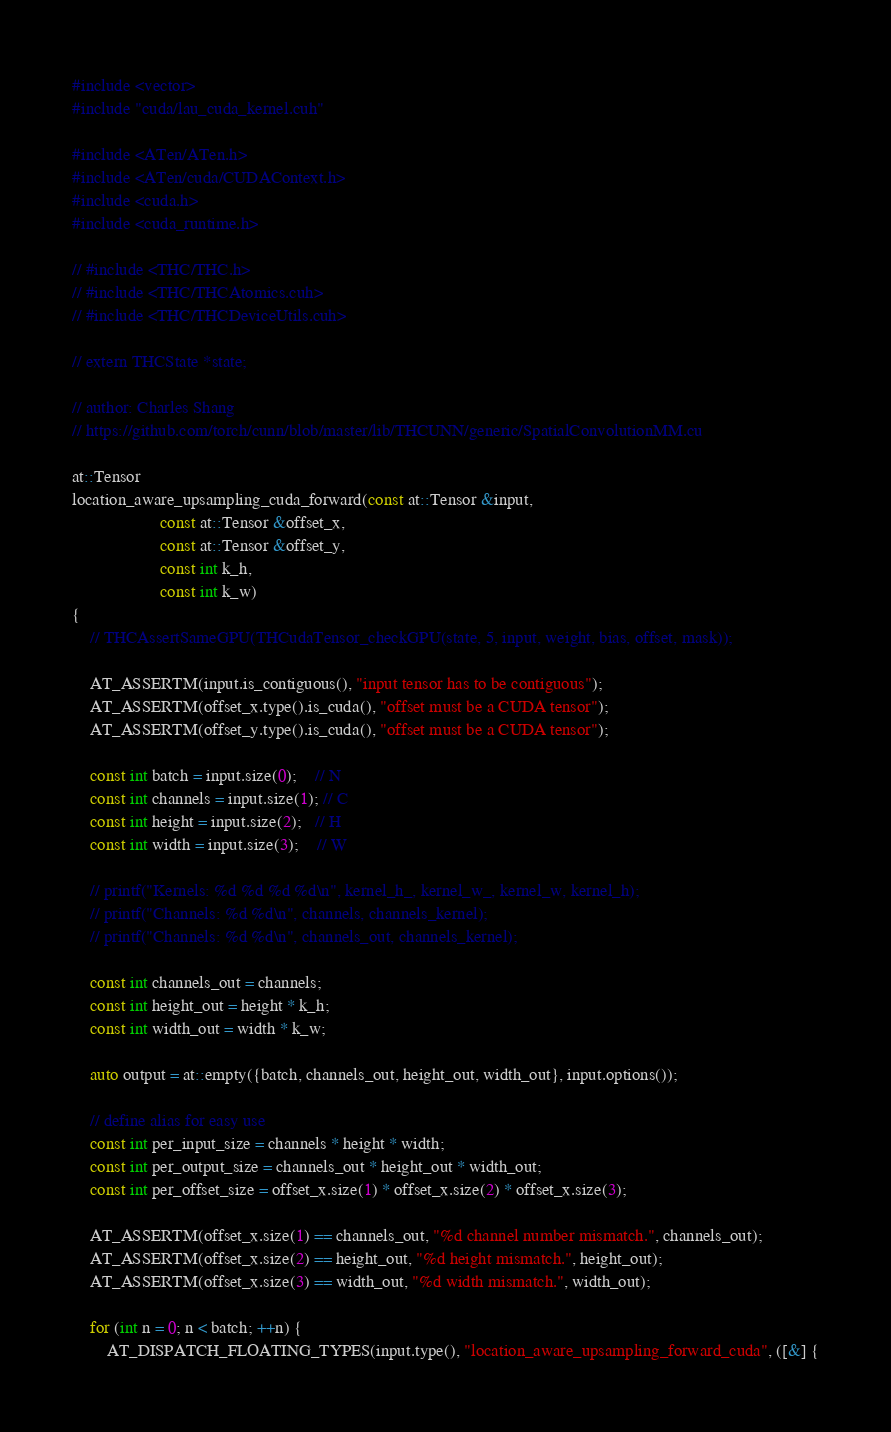<code> <loc_0><loc_0><loc_500><loc_500><_Cuda_>#include <vector>
#include "cuda/lau_cuda_kernel.cuh"

#include <ATen/ATen.h>
#include <ATen/cuda/CUDAContext.h>
#include <cuda.h>
#include <cuda_runtime.h>

// #include <THC/THC.h>
// #include <THC/THCAtomics.cuh>
// #include <THC/THCDeviceUtils.cuh>

// extern THCState *state;

// author: Charles Shang
// https://github.com/torch/cunn/blob/master/lib/THCUNN/generic/SpatialConvolutionMM.cu

at::Tensor
location_aware_upsampling_cuda_forward(const at::Tensor &input,
                    const at::Tensor &offset_x, 
                    const at::Tensor &offset_y, 
                    const int k_h,
                    const int k_w)
{
    // THCAssertSameGPU(THCudaTensor_checkGPU(state, 5, input, weight, bias, offset, mask));

    AT_ASSERTM(input.is_contiguous(), "input tensor has to be contiguous");
    AT_ASSERTM(offset_x.type().is_cuda(), "offset must be a CUDA tensor");
    AT_ASSERTM(offset_y.type().is_cuda(), "offset must be a CUDA tensor");

    const int batch = input.size(0);    // N
    const int channels = input.size(1); // C
    const int height = input.size(2);   // H
    const int width = input.size(3);    // W

    // printf("Kernels: %d %d %d %d\n", kernel_h_, kernel_w_, kernel_w, kernel_h);
    // printf("Channels: %d %d\n", channels, channels_kernel);
    // printf("Channels: %d %d\n", channels_out, channels_kernel);
    
    const int channels_out = channels;
    const int height_out = height * k_h;
    const int width_out = width * k_w;

    auto output = at::empty({batch, channels_out, height_out, width_out}, input.options());

    // define alias for easy use
    const int per_input_size = channels * height * width;
    const int per_output_size = channels_out * height_out * width_out;
    const int per_offset_size = offset_x.size(1) * offset_x.size(2) * offset_x.size(3);
    
    AT_ASSERTM(offset_x.size(1) == channels_out, "%d channel number mismatch.", channels_out);
    AT_ASSERTM(offset_x.size(2) == height_out, "%d height mismatch.", height_out);
    AT_ASSERTM(offset_x.size(3) == width_out, "%d width mismatch.", width_out);
    
    for (int n = 0; n < batch; ++n) {
        AT_DISPATCH_FLOATING_TYPES(input.type(), "location_aware_upsampling_forward_cuda", ([&] {</code> 